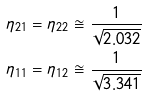Convert formula to latex. <formula><loc_0><loc_0><loc_500><loc_500>\eta _ { 2 1 } = \eta _ { 2 2 } \cong \frac { 1 } { \sqrt { 2 . 0 3 2 } } \\ \eta _ { 1 1 } = \eta _ { 1 2 } \cong \frac { 1 } { \sqrt { 3 . 3 4 1 } }</formula> 